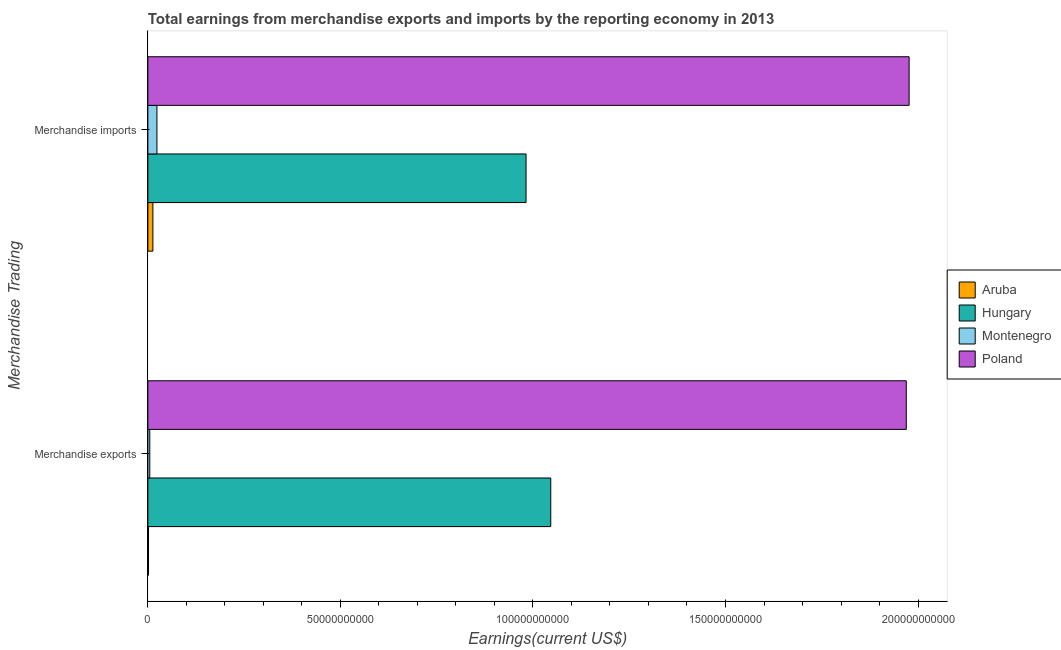Are the number of bars per tick equal to the number of legend labels?
Ensure brevity in your answer.  Yes. Are the number of bars on each tick of the Y-axis equal?
Give a very brief answer. Yes. What is the earnings from merchandise exports in Aruba?
Make the answer very short. 1.68e+08. Across all countries, what is the maximum earnings from merchandise imports?
Keep it short and to the point. 1.98e+11. Across all countries, what is the minimum earnings from merchandise imports?
Give a very brief answer. 1.30e+09. In which country was the earnings from merchandise exports minimum?
Ensure brevity in your answer.  Aruba. What is the total earnings from merchandise exports in the graph?
Your response must be concise. 3.02e+11. What is the difference between the earnings from merchandise imports in Poland and that in Aruba?
Your answer should be compact. 1.96e+11. What is the difference between the earnings from merchandise imports in Poland and the earnings from merchandise exports in Hungary?
Provide a succinct answer. 9.31e+1. What is the average earnings from merchandise exports per country?
Make the answer very short. 7.56e+1. What is the difference between the earnings from merchandise imports and earnings from merchandise exports in Hungary?
Offer a terse response. -6.42e+09. In how many countries, is the earnings from merchandise exports greater than 70000000000 US$?
Give a very brief answer. 2. What is the ratio of the earnings from merchandise exports in Poland to that in Hungary?
Ensure brevity in your answer.  1.88. Is the earnings from merchandise exports in Hungary less than that in Montenegro?
Make the answer very short. No. In how many countries, is the earnings from merchandise exports greater than the average earnings from merchandise exports taken over all countries?
Give a very brief answer. 2. What does the 4th bar from the top in Merchandise exports represents?
Provide a short and direct response. Aruba. What does the 1st bar from the bottom in Merchandise exports represents?
Your answer should be compact. Aruba. How many bars are there?
Keep it short and to the point. 8. What is the difference between two consecutive major ticks on the X-axis?
Provide a succinct answer. 5.00e+1. Are the values on the major ticks of X-axis written in scientific E-notation?
Keep it short and to the point. No. Does the graph contain any zero values?
Give a very brief answer. No. Does the graph contain grids?
Offer a terse response. No. How many legend labels are there?
Your answer should be very brief. 4. What is the title of the graph?
Your answer should be very brief. Total earnings from merchandise exports and imports by the reporting economy in 2013. Does "Slovak Republic" appear as one of the legend labels in the graph?
Give a very brief answer. No. What is the label or title of the X-axis?
Keep it short and to the point. Earnings(current US$). What is the label or title of the Y-axis?
Keep it short and to the point. Merchandise Trading. What is the Earnings(current US$) of Aruba in Merchandise exports?
Ensure brevity in your answer.  1.68e+08. What is the Earnings(current US$) in Hungary in Merchandise exports?
Provide a succinct answer. 1.05e+11. What is the Earnings(current US$) of Montenegro in Merchandise exports?
Ensure brevity in your answer.  4.98e+08. What is the Earnings(current US$) in Poland in Merchandise exports?
Your answer should be very brief. 1.97e+11. What is the Earnings(current US$) of Aruba in Merchandise imports?
Provide a succinct answer. 1.30e+09. What is the Earnings(current US$) in Hungary in Merchandise imports?
Ensure brevity in your answer.  9.82e+1. What is the Earnings(current US$) in Montenegro in Merchandise imports?
Keep it short and to the point. 2.35e+09. What is the Earnings(current US$) of Poland in Merchandise imports?
Provide a short and direct response. 1.98e+11. Across all Merchandise Trading, what is the maximum Earnings(current US$) of Aruba?
Your response must be concise. 1.30e+09. Across all Merchandise Trading, what is the maximum Earnings(current US$) in Hungary?
Provide a succinct answer. 1.05e+11. Across all Merchandise Trading, what is the maximum Earnings(current US$) of Montenegro?
Give a very brief answer. 2.35e+09. Across all Merchandise Trading, what is the maximum Earnings(current US$) of Poland?
Make the answer very short. 1.98e+11. Across all Merchandise Trading, what is the minimum Earnings(current US$) of Aruba?
Your response must be concise. 1.68e+08. Across all Merchandise Trading, what is the minimum Earnings(current US$) in Hungary?
Make the answer very short. 9.82e+1. Across all Merchandise Trading, what is the minimum Earnings(current US$) in Montenegro?
Ensure brevity in your answer.  4.98e+08. Across all Merchandise Trading, what is the minimum Earnings(current US$) of Poland?
Your response must be concise. 1.97e+11. What is the total Earnings(current US$) of Aruba in the graph?
Your answer should be compact. 1.47e+09. What is the total Earnings(current US$) of Hungary in the graph?
Keep it short and to the point. 2.03e+11. What is the total Earnings(current US$) of Montenegro in the graph?
Your answer should be very brief. 2.85e+09. What is the total Earnings(current US$) in Poland in the graph?
Give a very brief answer. 3.95e+11. What is the difference between the Earnings(current US$) in Aruba in Merchandise exports and that in Merchandise imports?
Offer a very short reply. -1.14e+09. What is the difference between the Earnings(current US$) in Hungary in Merchandise exports and that in Merchandise imports?
Offer a very short reply. 6.42e+09. What is the difference between the Earnings(current US$) of Montenegro in Merchandise exports and that in Merchandise imports?
Your answer should be compact. -1.86e+09. What is the difference between the Earnings(current US$) of Poland in Merchandise exports and that in Merchandise imports?
Your answer should be compact. -7.39e+08. What is the difference between the Earnings(current US$) in Aruba in Merchandise exports and the Earnings(current US$) in Hungary in Merchandise imports?
Offer a terse response. -9.80e+1. What is the difference between the Earnings(current US$) in Aruba in Merchandise exports and the Earnings(current US$) in Montenegro in Merchandise imports?
Your answer should be compact. -2.19e+09. What is the difference between the Earnings(current US$) of Aruba in Merchandise exports and the Earnings(current US$) of Poland in Merchandise imports?
Ensure brevity in your answer.  -1.98e+11. What is the difference between the Earnings(current US$) of Hungary in Merchandise exports and the Earnings(current US$) of Montenegro in Merchandise imports?
Keep it short and to the point. 1.02e+11. What is the difference between the Earnings(current US$) in Hungary in Merchandise exports and the Earnings(current US$) in Poland in Merchandise imports?
Provide a succinct answer. -9.31e+1. What is the difference between the Earnings(current US$) of Montenegro in Merchandise exports and the Earnings(current US$) of Poland in Merchandise imports?
Give a very brief answer. -1.97e+11. What is the average Earnings(current US$) in Aruba per Merchandise Trading?
Your answer should be compact. 7.36e+08. What is the average Earnings(current US$) of Hungary per Merchandise Trading?
Ensure brevity in your answer.  1.01e+11. What is the average Earnings(current US$) of Montenegro per Merchandise Trading?
Give a very brief answer. 1.43e+09. What is the average Earnings(current US$) in Poland per Merchandise Trading?
Your answer should be compact. 1.97e+11. What is the difference between the Earnings(current US$) in Aruba and Earnings(current US$) in Hungary in Merchandise exports?
Make the answer very short. -1.04e+11. What is the difference between the Earnings(current US$) in Aruba and Earnings(current US$) in Montenegro in Merchandise exports?
Provide a short and direct response. -3.30e+08. What is the difference between the Earnings(current US$) of Aruba and Earnings(current US$) of Poland in Merchandise exports?
Provide a succinct answer. -1.97e+11. What is the difference between the Earnings(current US$) in Hungary and Earnings(current US$) in Montenegro in Merchandise exports?
Your response must be concise. 1.04e+11. What is the difference between the Earnings(current US$) in Hungary and Earnings(current US$) in Poland in Merchandise exports?
Keep it short and to the point. -9.23e+1. What is the difference between the Earnings(current US$) of Montenegro and Earnings(current US$) of Poland in Merchandise exports?
Give a very brief answer. -1.96e+11. What is the difference between the Earnings(current US$) in Aruba and Earnings(current US$) in Hungary in Merchandise imports?
Give a very brief answer. -9.69e+1. What is the difference between the Earnings(current US$) of Aruba and Earnings(current US$) of Montenegro in Merchandise imports?
Your answer should be very brief. -1.05e+09. What is the difference between the Earnings(current US$) of Aruba and Earnings(current US$) of Poland in Merchandise imports?
Ensure brevity in your answer.  -1.96e+11. What is the difference between the Earnings(current US$) of Hungary and Earnings(current US$) of Montenegro in Merchandise imports?
Provide a succinct answer. 9.59e+1. What is the difference between the Earnings(current US$) of Hungary and Earnings(current US$) of Poland in Merchandise imports?
Your answer should be very brief. -9.95e+1. What is the difference between the Earnings(current US$) of Montenegro and Earnings(current US$) of Poland in Merchandise imports?
Provide a succinct answer. -1.95e+11. What is the ratio of the Earnings(current US$) of Aruba in Merchandise exports to that in Merchandise imports?
Give a very brief answer. 0.13. What is the ratio of the Earnings(current US$) in Hungary in Merchandise exports to that in Merchandise imports?
Provide a short and direct response. 1.07. What is the ratio of the Earnings(current US$) of Montenegro in Merchandise exports to that in Merchandise imports?
Offer a very short reply. 0.21. What is the ratio of the Earnings(current US$) in Poland in Merchandise exports to that in Merchandise imports?
Ensure brevity in your answer.  1. What is the difference between the highest and the second highest Earnings(current US$) in Aruba?
Give a very brief answer. 1.14e+09. What is the difference between the highest and the second highest Earnings(current US$) in Hungary?
Your answer should be very brief. 6.42e+09. What is the difference between the highest and the second highest Earnings(current US$) of Montenegro?
Provide a succinct answer. 1.86e+09. What is the difference between the highest and the second highest Earnings(current US$) in Poland?
Offer a very short reply. 7.39e+08. What is the difference between the highest and the lowest Earnings(current US$) of Aruba?
Ensure brevity in your answer.  1.14e+09. What is the difference between the highest and the lowest Earnings(current US$) in Hungary?
Provide a short and direct response. 6.42e+09. What is the difference between the highest and the lowest Earnings(current US$) of Montenegro?
Offer a terse response. 1.86e+09. What is the difference between the highest and the lowest Earnings(current US$) in Poland?
Give a very brief answer. 7.39e+08. 